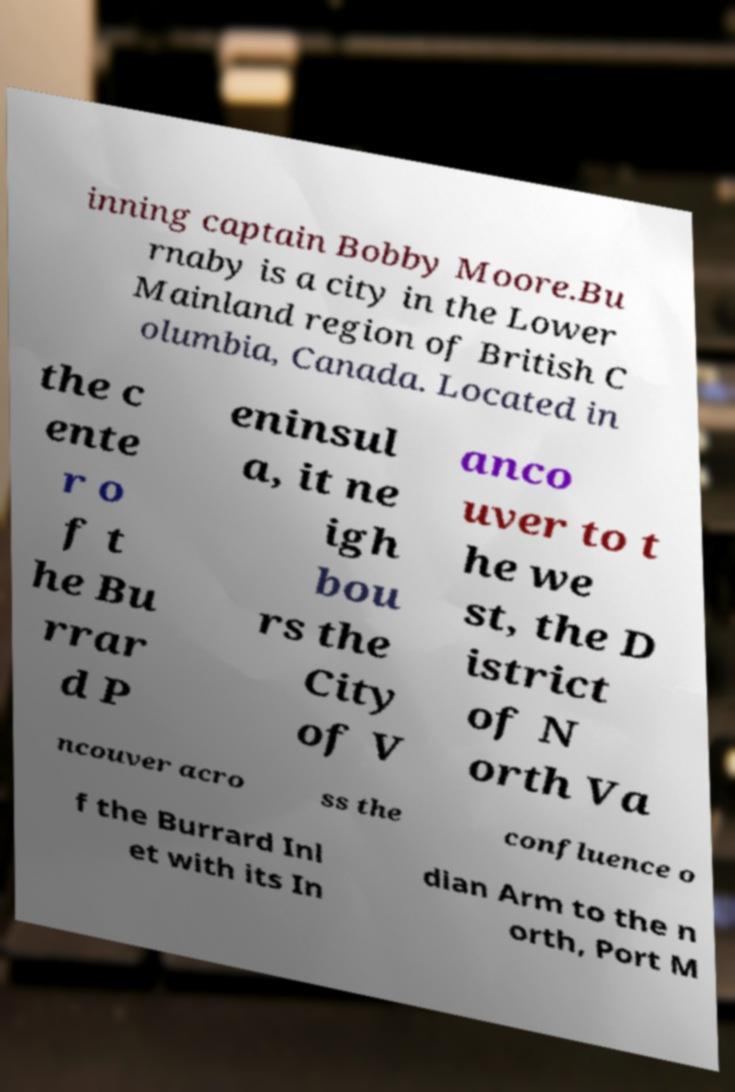There's text embedded in this image that I need extracted. Can you transcribe it verbatim? inning captain Bobby Moore.Bu rnaby is a city in the Lower Mainland region of British C olumbia, Canada. Located in the c ente r o f t he Bu rrar d P eninsul a, it ne igh bou rs the City of V anco uver to t he we st, the D istrict of N orth Va ncouver acro ss the confluence o f the Burrard Inl et with its In dian Arm to the n orth, Port M 